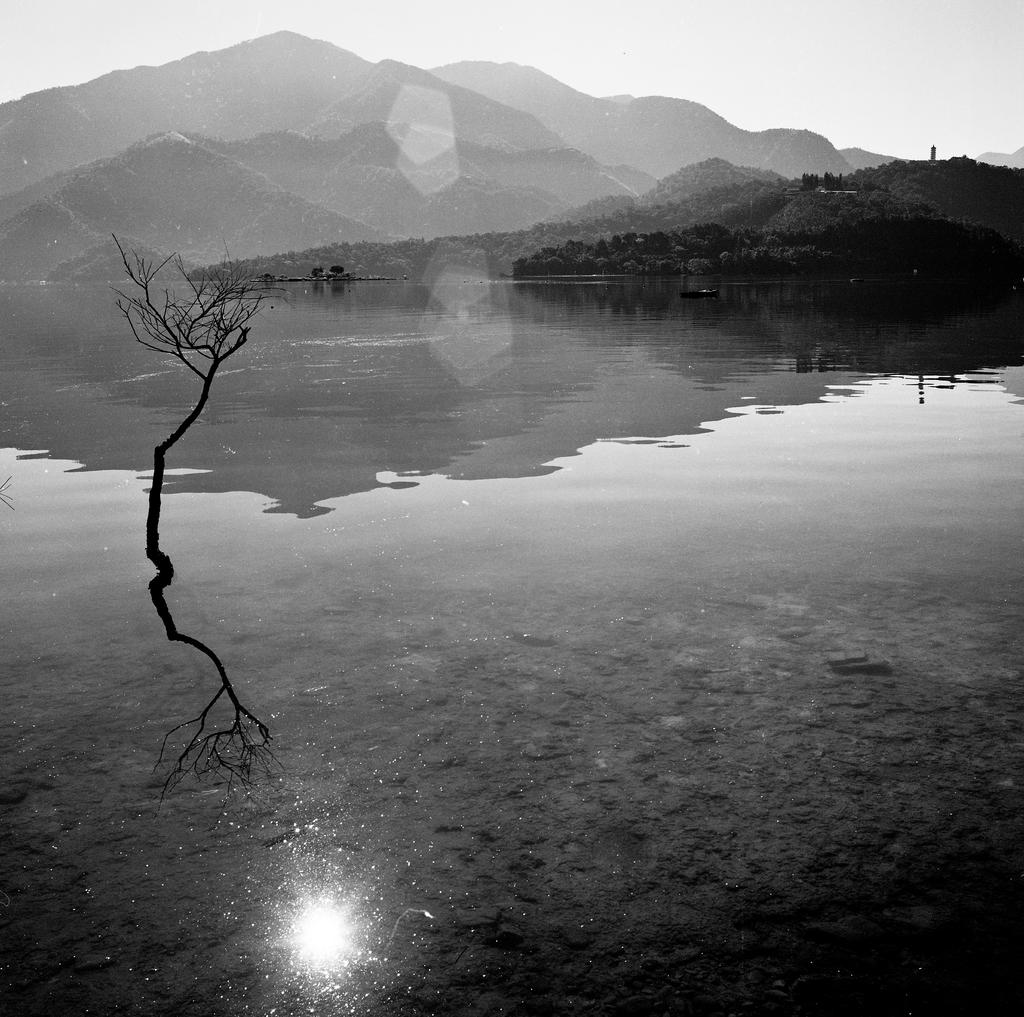What is the color scheme of the image? The image is black and white. What natural element can be seen in the image? There is water visible in the image. What type of plant is present in the image? There is a tree in the image. What can be seen in the distance in the image? There are hills in the background of the image. What is visible above the hills in the image? The sky is visible in the background of the image. What type of waste is being disposed of in the image? There is no waste present in the image; it features a black and white scene with water, a tree, hills, and the sky. 